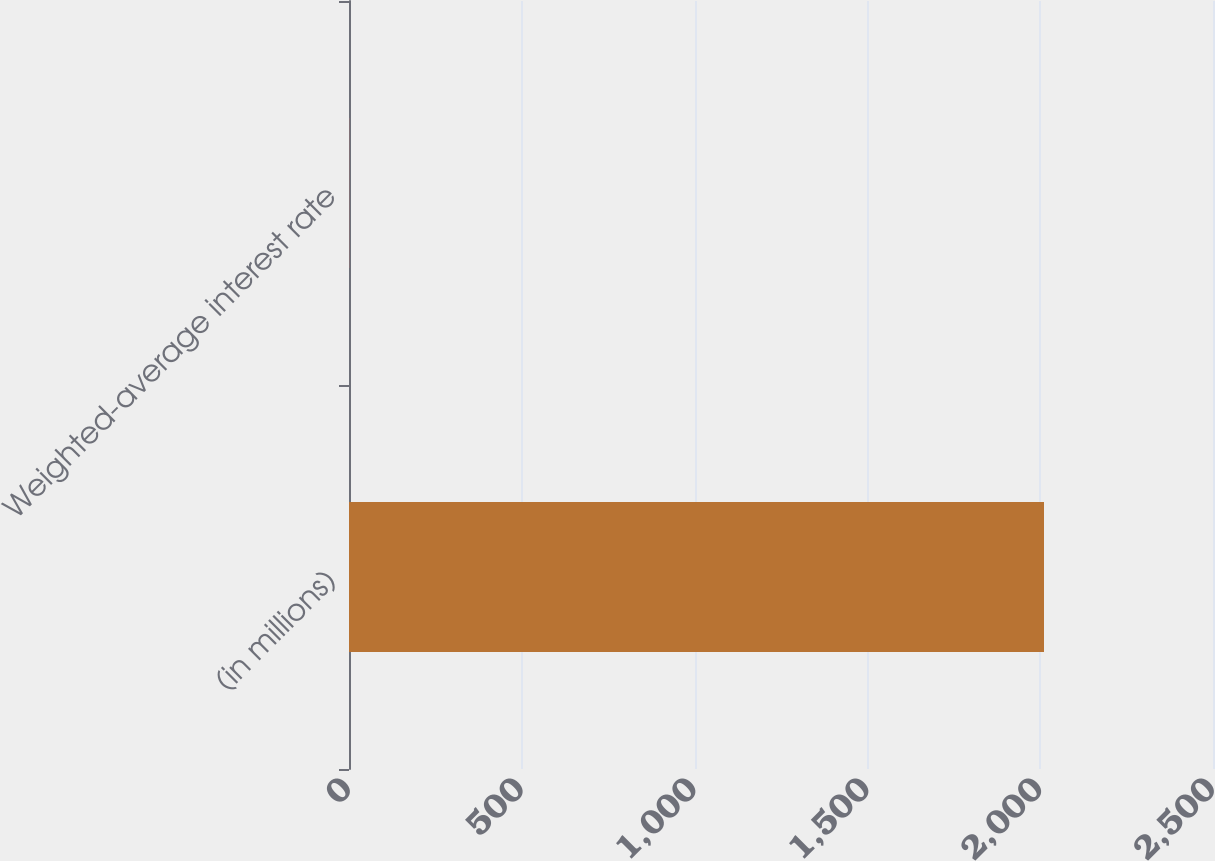<chart> <loc_0><loc_0><loc_500><loc_500><bar_chart><fcel>(in millions)<fcel>Weighted-average interest rate<nl><fcel>2011<fcel>0.4<nl></chart> 